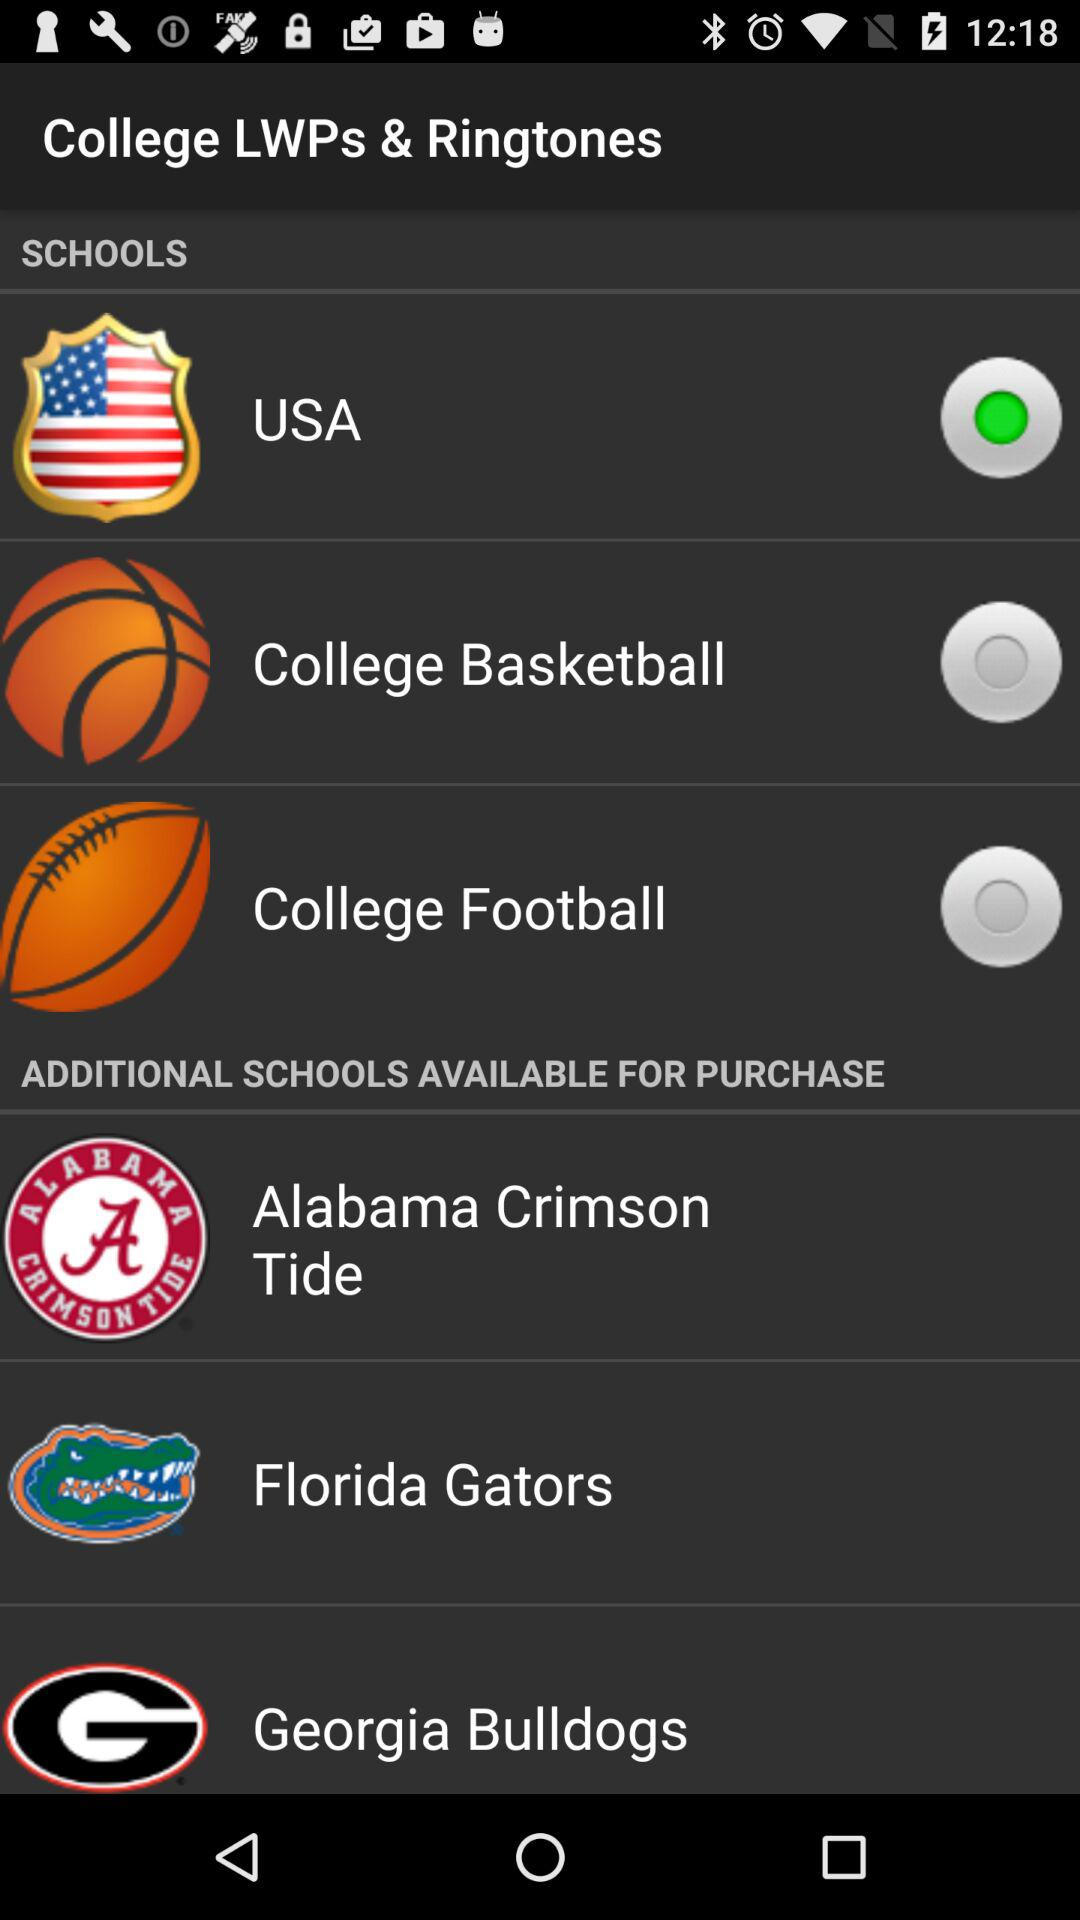Which option is selected? The selected option is the USA. 